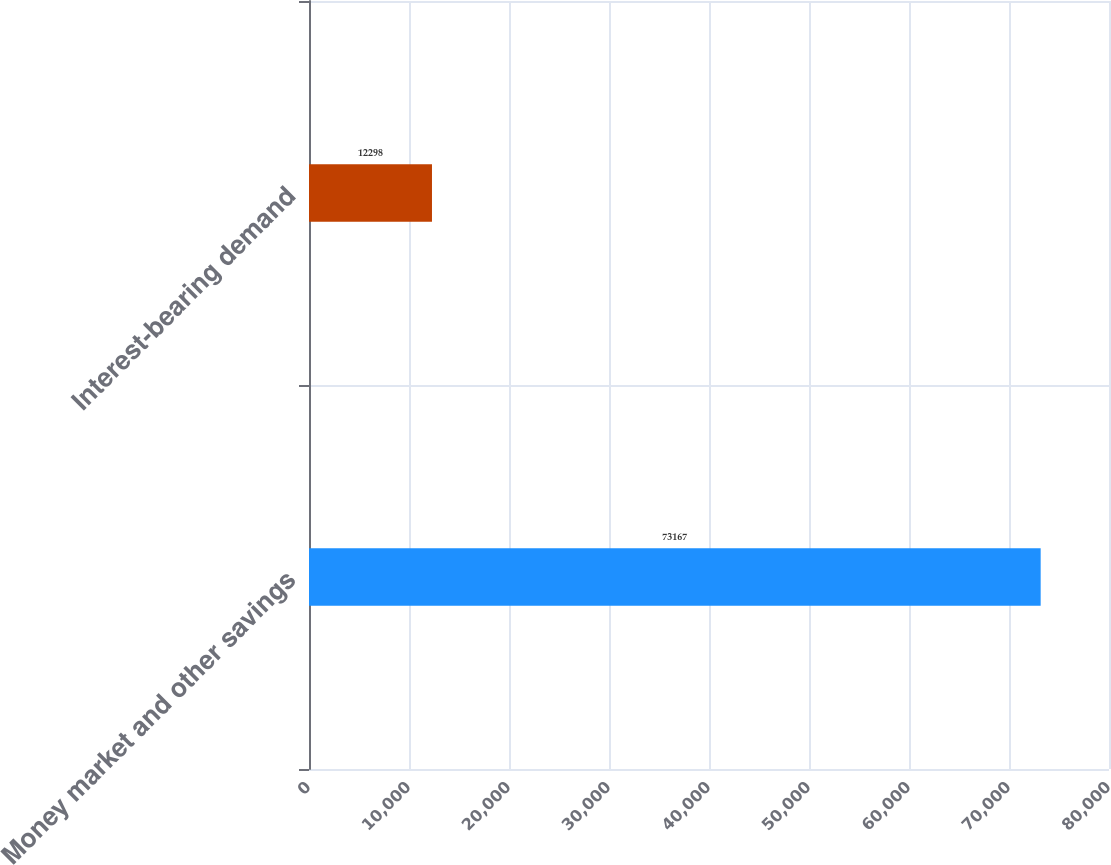Convert chart. <chart><loc_0><loc_0><loc_500><loc_500><bar_chart><fcel>Money market and other savings<fcel>Interest-bearing demand<nl><fcel>73167<fcel>12298<nl></chart> 